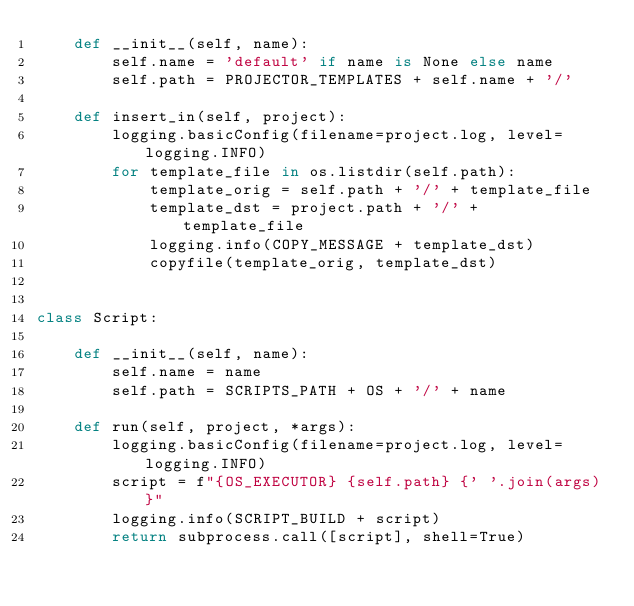Convert code to text. <code><loc_0><loc_0><loc_500><loc_500><_Python_>    def __init__(self, name):
        self.name = 'default' if name is None else name
        self.path = PROJECTOR_TEMPLATES + self.name + '/'

    def insert_in(self, project):
        logging.basicConfig(filename=project.log, level=logging.INFO)
        for template_file in os.listdir(self.path):
            template_orig = self.path + '/' + template_file
            template_dst = project.path + '/' + template_file
            logging.info(COPY_MESSAGE + template_dst)
            copyfile(template_orig, template_dst)


class Script:

    def __init__(self, name):
        self.name = name
        self.path = SCRIPTS_PATH + OS + '/' + name

    def run(self, project, *args):
        logging.basicConfig(filename=project.log, level=logging.INFO)
        script = f"{OS_EXECUTOR} {self.path} {' '.join(args)}"
        logging.info(SCRIPT_BUILD + script)
        return subprocess.call([script], shell=True)
</code> 